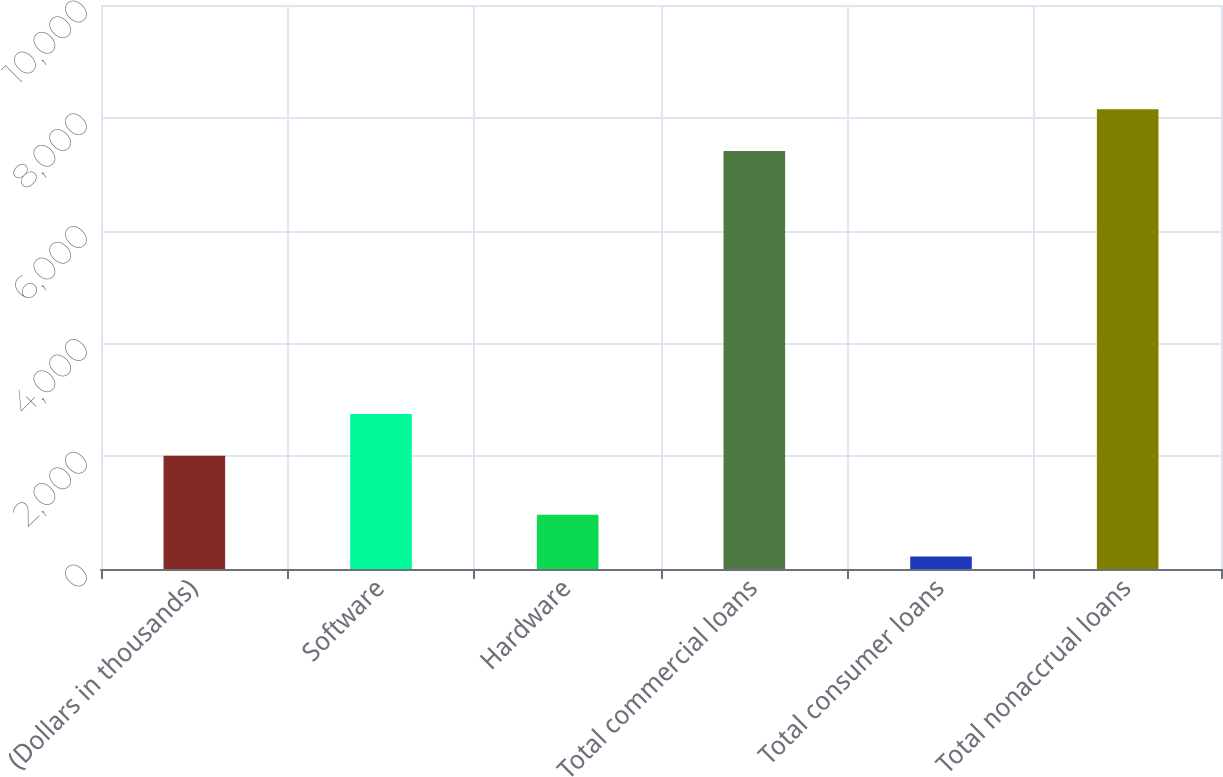Convert chart. <chart><loc_0><loc_0><loc_500><loc_500><bar_chart><fcel>(Dollars in thousands)<fcel>Software<fcel>Hardware<fcel>Total commercial loans<fcel>Total consumer loans<fcel>Total nonaccrual loans<nl><fcel>2007<fcel>2748.2<fcel>963.2<fcel>7412<fcel>222<fcel>8153.2<nl></chart> 